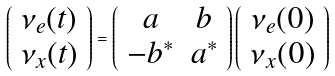<formula> <loc_0><loc_0><loc_500><loc_500>\left ( \begin{array} { c } \nu _ { e } ( t ) \\ \nu _ { x } ( t ) \end{array} \right ) = \left ( \begin{array} { c c } a & b \\ - b ^ { * } & a ^ { * } \end{array} \right ) \left ( \begin{array} { c } \nu _ { e } ( 0 ) \\ \nu _ { x } ( 0 ) \end{array} \right )</formula> 